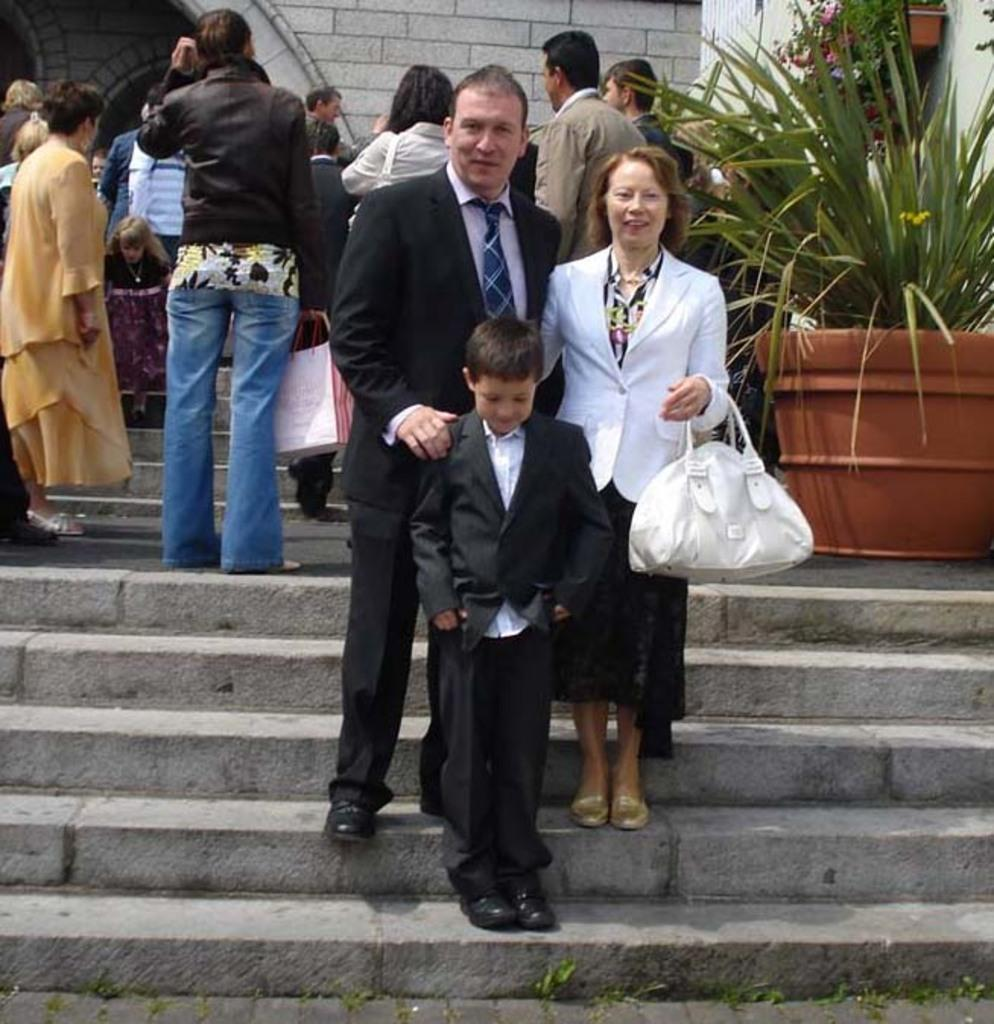How many people are present in the image? There are three people in the image: a man, a woman, and a child. What are the expressions of the people in the image? Both the man and the woman are smiling in the image. Where are the man, woman, and child located in the image? They are on the steps in the image. What can be seen in the background of the image? There are people and a plant in the background of the image. Can you see any waves in the image? There are no waves present in the image. Is there a lake visible in the background of the image? There is no lake visible in the image; only people and a plant can be seen in the background. 